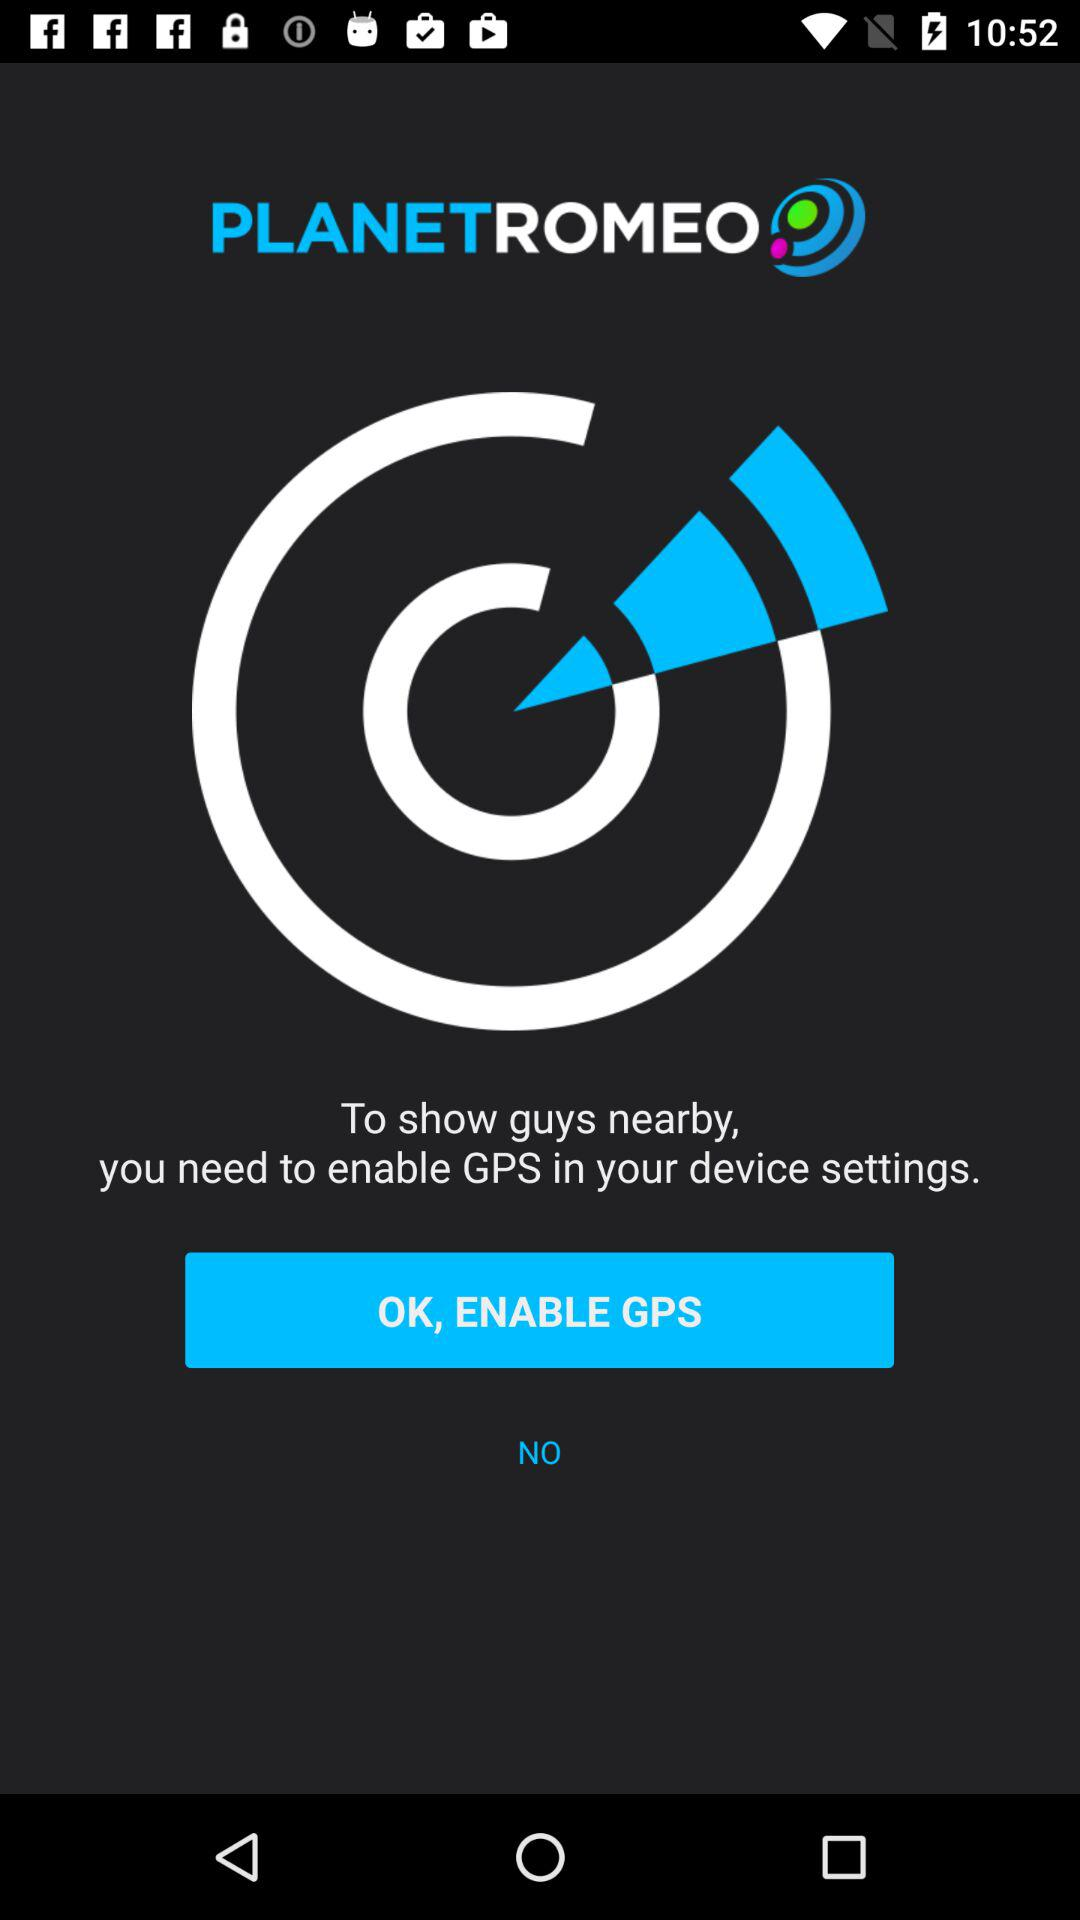What is the app name? The app name is "PLANETROMEO". 